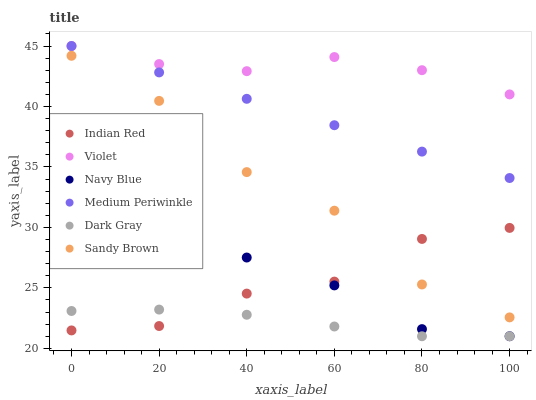Does Dark Gray have the minimum area under the curve?
Answer yes or no. Yes. Does Violet have the maximum area under the curve?
Answer yes or no. Yes. Does Medium Periwinkle have the minimum area under the curve?
Answer yes or no. No. Does Medium Periwinkle have the maximum area under the curve?
Answer yes or no. No. Is Medium Periwinkle the smoothest?
Answer yes or no. Yes. Is Sandy Brown the roughest?
Answer yes or no. Yes. Is Dark Gray the smoothest?
Answer yes or no. No. Is Dark Gray the roughest?
Answer yes or no. No. Does Navy Blue have the lowest value?
Answer yes or no. Yes. Does Medium Periwinkle have the lowest value?
Answer yes or no. No. Does Violet have the highest value?
Answer yes or no. Yes. Does Dark Gray have the highest value?
Answer yes or no. No. Is Navy Blue less than Medium Periwinkle?
Answer yes or no. Yes. Is Sandy Brown greater than Navy Blue?
Answer yes or no. Yes. Does Indian Red intersect Sandy Brown?
Answer yes or no. Yes. Is Indian Red less than Sandy Brown?
Answer yes or no. No. Is Indian Red greater than Sandy Brown?
Answer yes or no. No. Does Navy Blue intersect Medium Periwinkle?
Answer yes or no. No. 